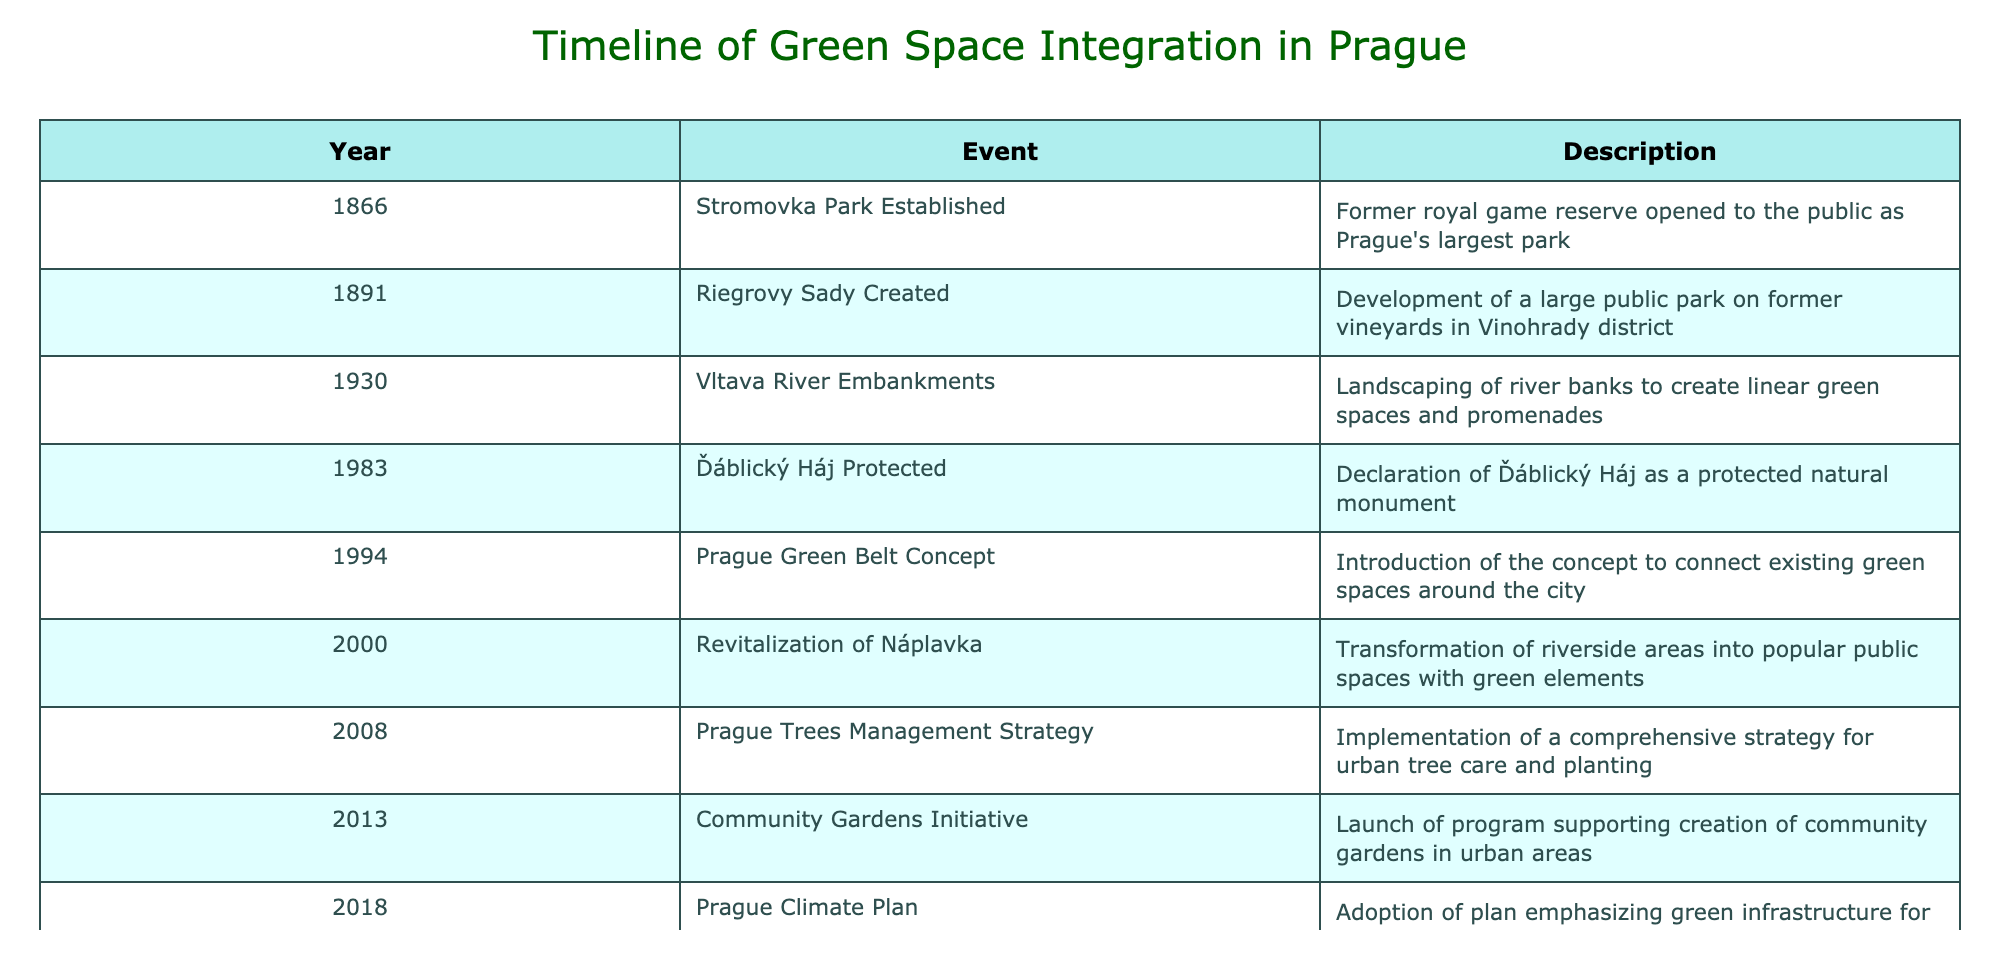What year was Stromovka Park established? Stromovka Park is mentioned as being established in the year 1866 in the table.
Answer: 1866 In what year did the Vltava River Embankments get landscaped? According to the table, the landscaping event for the Vltava River Embankments took place in 1930.
Answer: 1930 How many major initiatives for green space integration were introduced after 2000? From the table, the initiatives introduced after 2000 are: Revitalization of Náplavka (2000), Prague Trees Management Strategy (2008), Community Gardens Initiative (2013), Prague Climate Plan (2018), Roof Garden Incentives (2020), and Vítkov Hill Redevelopment (2022). Counting these gives us a total of six events.
Answer: 6 Was the Ďáblický Háj ever declared as a protected natural monument? The table states that Ďáblický Háj was declared as a protected natural monument in 1983, so the answer is yes.
Answer: Yes What is the difference between the years when the Prague Climate Plan and Roof Garden Incentives were introduced? The Prague Climate Plan was adopted in 2018 and the Roof Garden Incentives were introduced in 2020. The difference in years is 2020 - 2018 = 2 years.
Answer: 2 years Which decade saw the introduction of the Prague Green Belt Concept? The Prague Green Belt Concept was introduced in 1994, which falls within the 1990s decade.
Answer: 1990s How many events are listed for the 21st century? In the table, the events listed for the 21st century starting from the year 2000 are: Revitalization of Náplavka (2000), Prague Trees Management Strategy (2008), Community Gardens Initiative (2013), Prague Climate Plan (2018), Roof Garden Incentives (2020), and Vítkov Hill Redevelopment (2022). Counting these gives a total of six events.
Answer: 6 Did the Vítkov Hill Redevelopment project start before the Community Gardens Initiative? The Vítkov Hill Redevelopment project began in 2022 while the Community Gardens Initiative was launched in 2013. Since 2022 is after 2013, the answer is no.
Answer: No What is the earliest event related to green space integration in Prague according to the table? The earliest event listed is the establishment of Stromovka Park in 1866, making it the first related to green space integration.
Answer: 1866 